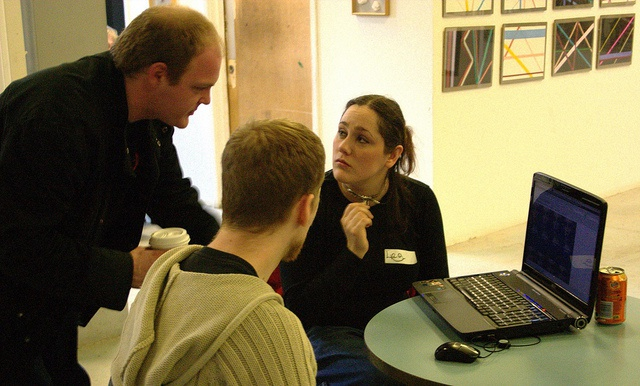Describe the objects in this image and their specific colors. I can see people in tan, black, maroon, and brown tones, people in tan, olive, and black tones, people in tan, black, olive, and maroon tones, laptop in tan, black, olive, navy, and gray tones, and mouse in tan, black, and olive tones in this image. 